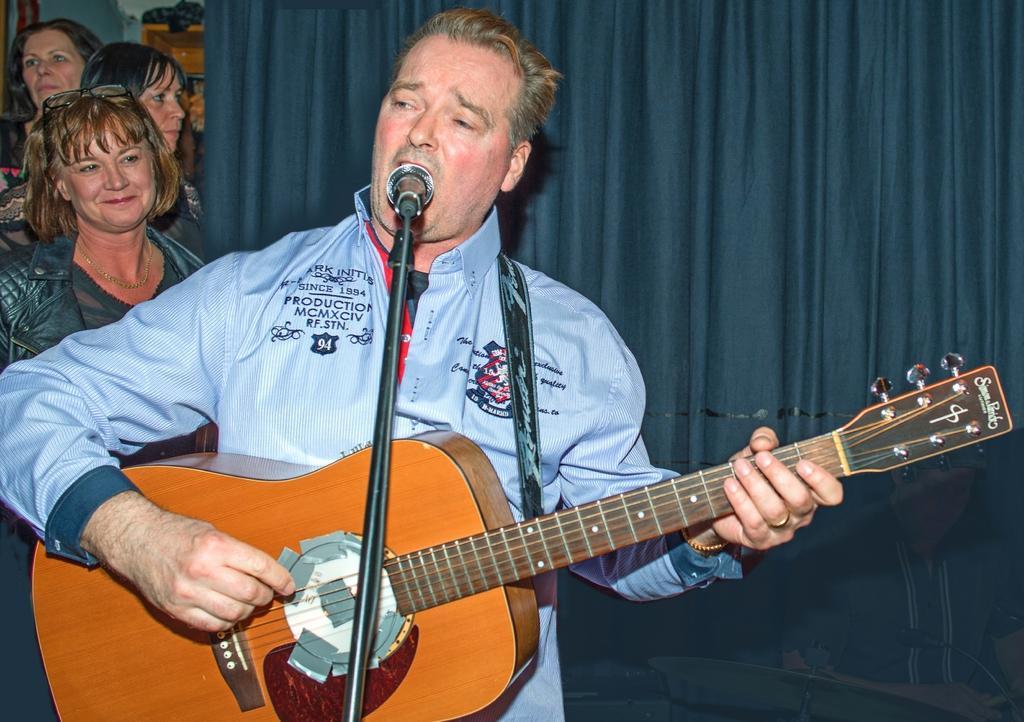In one or two sentences, can you explain what this image depicts? In the middle of the image a man is standing and playing guitar and singing on the microphone. Behind him there is a curtain. Top left side of the image three women are standing and watching. 